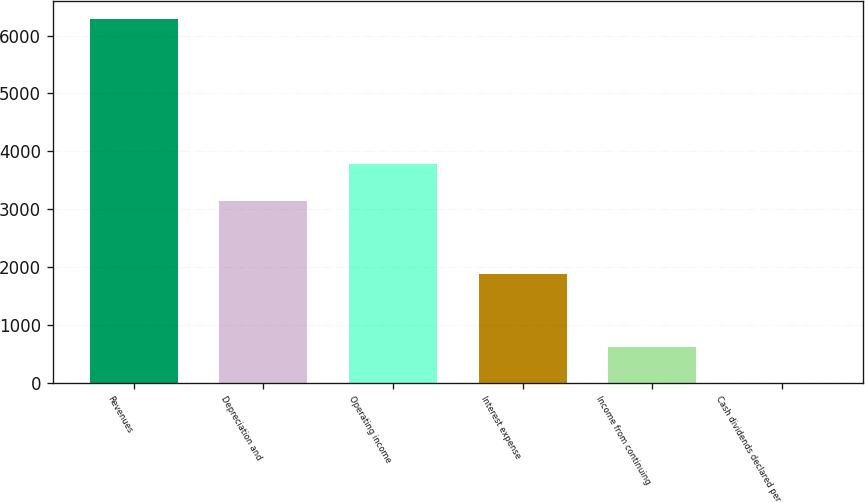Convert chart. <chart><loc_0><loc_0><loc_500><loc_500><bar_chart><fcel>Revenues<fcel>Depreciation and<fcel>Operating income<fcel>Interest expense<fcel>Income from continuing<fcel>Cash dividends declared per<nl><fcel>6288<fcel>3144.49<fcel>3773.19<fcel>1887.07<fcel>629.66<fcel>0.95<nl></chart> 